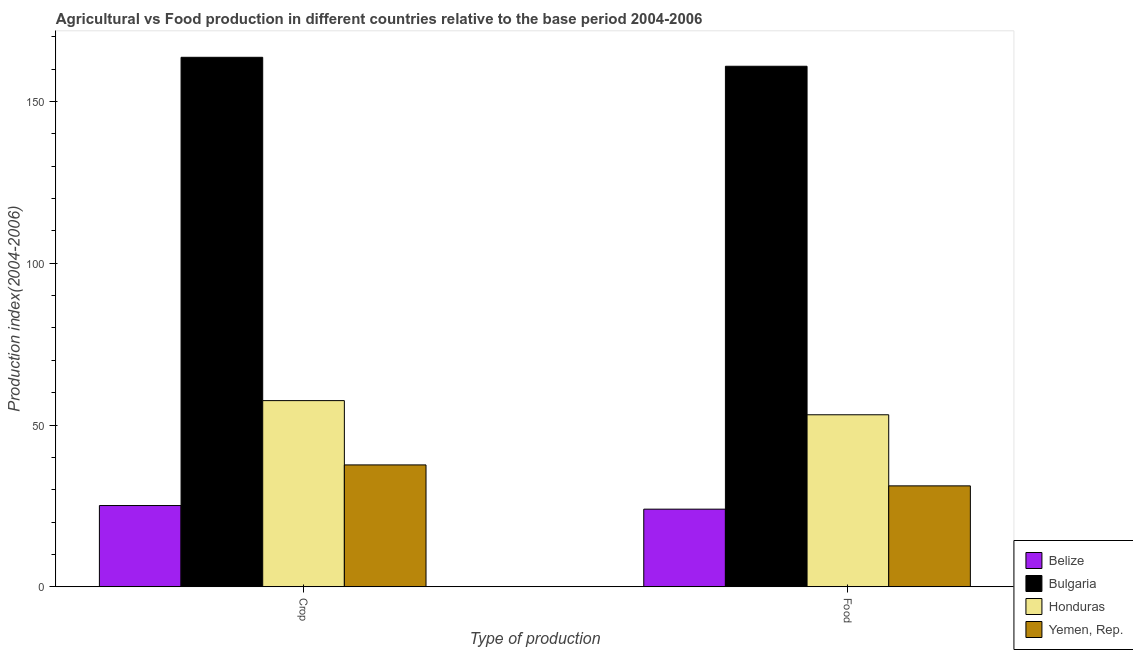How many different coloured bars are there?
Keep it short and to the point. 4. Are the number of bars per tick equal to the number of legend labels?
Keep it short and to the point. Yes. How many bars are there on the 2nd tick from the left?
Offer a very short reply. 4. What is the label of the 1st group of bars from the left?
Keep it short and to the point. Crop. What is the food production index in Yemen, Rep.?
Your response must be concise. 31.19. Across all countries, what is the maximum crop production index?
Make the answer very short. 163.69. Across all countries, what is the minimum crop production index?
Give a very brief answer. 25.11. In which country was the crop production index maximum?
Make the answer very short. Bulgaria. In which country was the crop production index minimum?
Provide a succinct answer. Belize. What is the total crop production index in the graph?
Offer a very short reply. 284.02. What is the difference between the crop production index in Yemen, Rep. and that in Belize?
Offer a very short reply. 12.56. What is the difference between the crop production index in Yemen, Rep. and the food production index in Belize?
Provide a short and direct response. 13.68. What is the average crop production index per country?
Provide a short and direct response. 71.01. What is the difference between the food production index and crop production index in Belize?
Your response must be concise. -1.12. In how many countries, is the food production index greater than 50 ?
Your answer should be compact. 2. What is the ratio of the crop production index in Honduras to that in Bulgaria?
Provide a succinct answer. 0.35. In how many countries, is the food production index greater than the average food production index taken over all countries?
Your answer should be compact. 1. What does the 4th bar from the left in Crop represents?
Your answer should be very brief. Yemen, Rep. What does the 4th bar from the right in Crop represents?
Keep it short and to the point. Belize. Are all the bars in the graph horizontal?
Your response must be concise. No. How many countries are there in the graph?
Keep it short and to the point. 4. What is the difference between two consecutive major ticks on the Y-axis?
Provide a short and direct response. 50. Are the values on the major ticks of Y-axis written in scientific E-notation?
Keep it short and to the point. No. Does the graph contain any zero values?
Your answer should be compact. No. Does the graph contain grids?
Give a very brief answer. No. How many legend labels are there?
Offer a terse response. 4. What is the title of the graph?
Provide a short and direct response. Agricultural vs Food production in different countries relative to the base period 2004-2006. Does "Saudi Arabia" appear as one of the legend labels in the graph?
Make the answer very short. No. What is the label or title of the X-axis?
Your answer should be very brief. Type of production. What is the label or title of the Y-axis?
Provide a short and direct response. Production index(2004-2006). What is the Production index(2004-2006) in Belize in Crop?
Offer a terse response. 25.11. What is the Production index(2004-2006) in Bulgaria in Crop?
Provide a short and direct response. 163.69. What is the Production index(2004-2006) of Honduras in Crop?
Your answer should be very brief. 57.55. What is the Production index(2004-2006) in Yemen, Rep. in Crop?
Your answer should be very brief. 37.67. What is the Production index(2004-2006) of Belize in Food?
Your answer should be compact. 23.99. What is the Production index(2004-2006) of Bulgaria in Food?
Your answer should be very brief. 160.92. What is the Production index(2004-2006) of Honduras in Food?
Your answer should be compact. 53.17. What is the Production index(2004-2006) in Yemen, Rep. in Food?
Provide a short and direct response. 31.19. Across all Type of production, what is the maximum Production index(2004-2006) in Belize?
Provide a short and direct response. 25.11. Across all Type of production, what is the maximum Production index(2004-2006) of Bulgaria?
Make the answer very short. 163.69. Across all Type of production, what is the maximum Production index(2004-2006) in Honduras?
Give a very brief answer. 57.55. Across all Type of production, what is the maximum Production index(2004-2006) of Yemen, Rep.?
Offer a very short reply. 37.67. Across all Type of production, what is the minimum Production index(2004-2006) in Belize?
Provide a succinct answer. 23.99. Across all Type of production, what is the minimum Production index(2004-2006) of Bulgaria?
Your answer should be very brief. 160.92. Across all Type of production, what is the minimum Production index(2004-2006) of Honduras?
Provide a succinct answer. 53.17. Across all Type of production, what is the minimum Production index(2004-2006) of Yemen, Rep.?
Keep it short and to the point. 31.19. What is the total Production index(2004-2006) of Belize in the graph?
Give a very brief answer. 49.1. What is the total Production index(2004-2006) in Bulgaria in the graph?
Your response must be concise. 324.61. What is the total Production index(2004-2006) of Honduras in the graph?
Provide a short and direct response. 110.72. What is the total Production index(2004-2006) of Yemen, Rep. in the graph?
Offer a very short reply. 68.86. What is the difference between the Production index(2004-2006) in Belize in Crop and that in Food?
Your response must be concise. 1.12. What is the difference between the Production index(2004-2006) of Bulgaria in Crop and that in Food?
Keep it short and to the point. 2.77. What is the difference between the Production index(2004-2006) in Honduras in Crop and that in Food?
Ensure brevity in your answer.  4.38. What is the difference between the Production index(2004-2006) in Yemen, Rep. in Crop and that in Food?
Make the answer very short. 6.48. What is the difference between the Production index(2004-2006) of Belize in Crop and the Production index(2004-2006) of Bulgaria in Food?
Give a very brief answer. -135.81. What is the difference between the Production index(2004-2006) in Belize in Crop and the Production index(2004-2006) in Honduras in Food?
Keep it short and to the point. -28.06. What is the difference between the Production index(2004-2006) of Belize in Crop and the Production index(2004-2006) of Yemen, Rep. in Food?
Your answer should be very brief. -6.08. What is the difference between the Production index(2004-2006) in Bulgaria in Crop and the Production index(2004-2006) in Honduras in Food?
Your response must be concise. 110.52. What is the difference between the Production index(2004-2006) in Bulgaria in Crop and the Production index(2004-2006) in Yemen, Rep. in Food?
Your answer should be compact. 132.5. What is the difference between the Production index(2004-2006) in Honduras in Crop and the Production index(2004-2006) in Yemen, Rep. in Food?
Provide a succinct answer. 26.36. What is the average Production index(2004-2006) in Belize per Type of production?
Offer a terse response. 24.55. What is the average Production index(2004-2006) of Bulgaria per Type of production?
Offer a very short reply. 162.31. What is the average Production index(2004-2006) of Honduras per Type of production?
Your answer should be very brief. 55.36. What is the average Production index(2004-2006) of Yemen, Rep. per Type of production?
Your response must be concise. 34.43. What is the difference between the Production index(2004-2006) in Belize and Production index(2004-2006) in Bulgaria in Crop?
Make the answer very short. -138.58. What is the difference between the Production index(2004-2006) of Belize and Production index(2004-2006) of Honduras in Crop?
Ensure brevity in your answer.  -32.44. What is the difference between the Production index(2004-2006) of Belize and Production index(2004-2006) of Yemen, Rep. in Crop?
Ensure brevity in your answer.  -12.56. What is the difference between the Production index(2004-2006) of Bulgaria and Production index(2004-2006) of Honduras in Crop?
Your answer should be compact. 106.14. What is the difference between the Production index(2004-2006) of Bulgaria and Production index(2004-2006) of Yemen, Rep. in Crop?
Ensure brevity in your answer.  126.02. What is the difference between the Production index(2004-2006) in Honduras and Production index(2004-2006) in Yemen, Rep. in Crop?
Keep it short and to the point. 19.88. What is the difference between the Production index(2004-2006) of Belize and Production index(2004-2006) of Bulgaria in Food?
Provide a succinct answer. -136.93. What is the difference between the Production index(2004-2006) of Belize and Production index(2004-2006) of Honduras in Food?
Offer a very short reply. -29.18. What is the difference between the Production index(2004-2006) in Bulgaria and Production index(2004-2006) in Honduras in Food?
Your answer should be compact. 107.75. What is the difference between the Production index(2004-2006) in Bulgaria and Production index(2004-2006) in Yemen, Rep. in Food?
Give a very brief answer. 129.73. What is the difference between the Production index(2004-2006) of Honduras and Production index(2004-2006) of Yemen, Rep. in Food?
Provide a short and direct response. 21.98. What is the ratio of the Production index(2004-2006) of Belize in Crop to that in Food?
Your answer should be compact. 1.05. What is the ratio of the Production index(2004-2006) of Bulgaria in Crop to that in Food?
Your response must be concise. 1.02. What is the ratio of the Production index(2004-2006) of Honduras in Crop to that in Food?
Give a very brief answer. 1.08. What is the ratio of the Production index(2004-2006) in Yemen, Rep. in Crop to that in Food?
Ensure brevity in your answer.  1.21. What is the difference between the highest and the second highest Production index(2004-2006) of Belize?
Offer a very short reply. 1.12. What is the difference between the highest and the second highest Production index(2004-2006) of Bulgaria?
Provide a short and direct response. 2.77. What is the difference between the highest and the second highest Production index(2004-2006) of Honduras?
Your answer should be compact. 4.38. What is the difference between the highest and the second highest Production index(2004-2006) in Yemen, Rep.?
Keep it short and to the point. 6.48. What is the difference between the highest and the lowest Production index(2004-2006) in Belize?
Provide a succinct answer. 1.12. What is the difference between the highest and the lowest Production index(2004-2006) of Bulgaria?
Provide a succinct answer. 2.77. What is the difference between the highest and the lowest Production index(2004-2006) of Honduras?
Your answer should be compact. 4.38. What is the difference between the highest and the lowest Production index(2004-2006) of Yemen, Rep.?
Your answer should be compact. 6.48. 